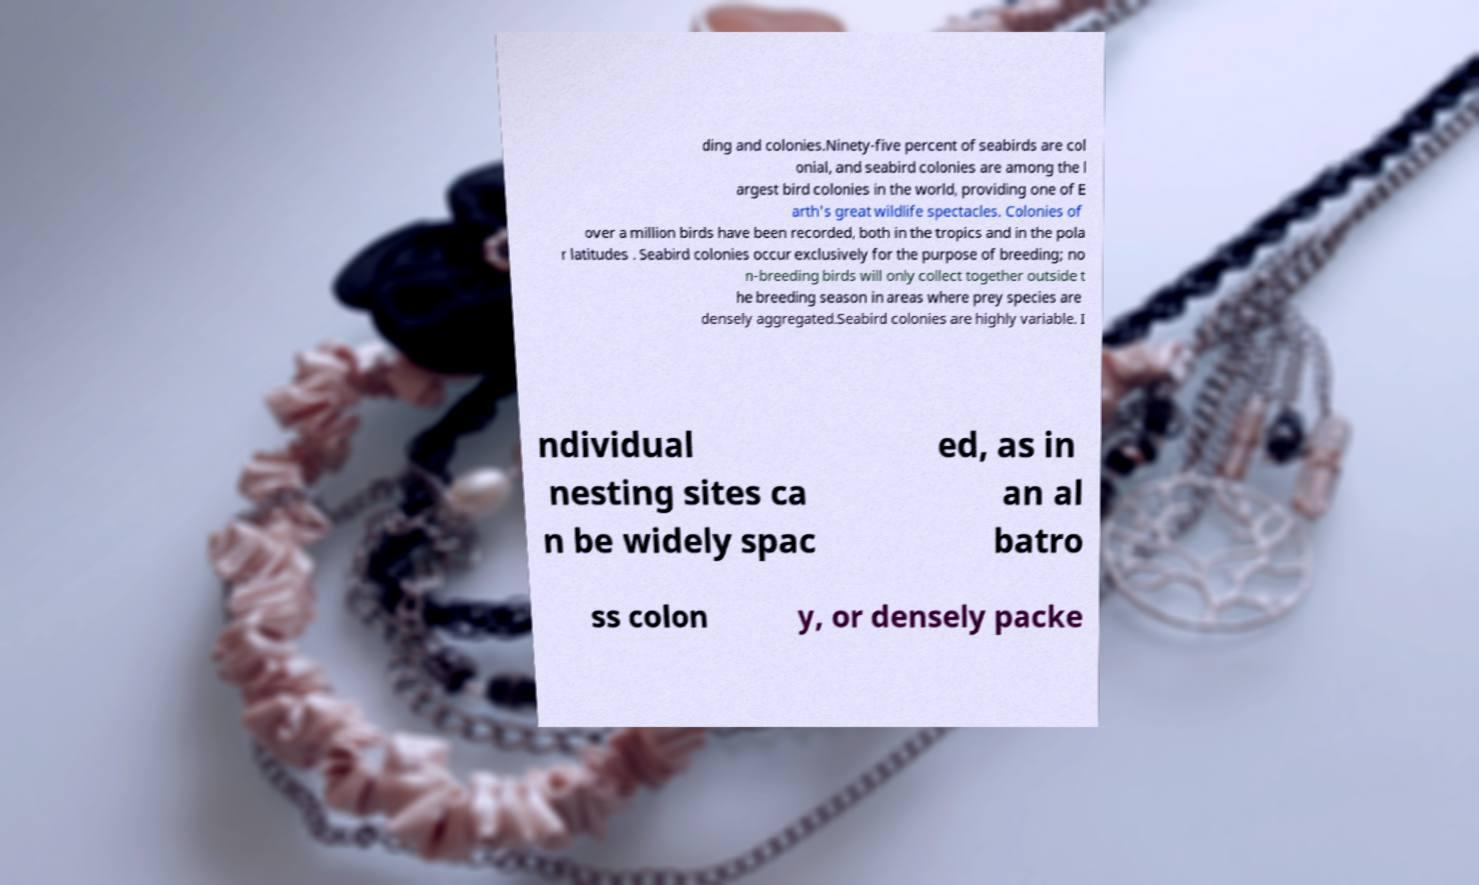Can you read and provide the text displayed in the image?This photo seems to have some interesting text. Can you extract and type it out for me? ding and colonies.Ninety-five percent of seabirds are col onial, and seabird colonies are among the l argest bird colonies in the world, providing one of E arth's great wildlife spectacles. Colonies of over a million birds have been recorded, both in the tropics and in the pola r latitudes . Seabird colonies occur exclusively for the purpose of breeding; no n-breeding birds will only collect together outside t he breeding season in areas where prey species are densely aggregated.Seabird colonies are highly variable. I ndividual nesting sites ca n be widely spac ed, as in an al batro ss colon y, or densely packe 